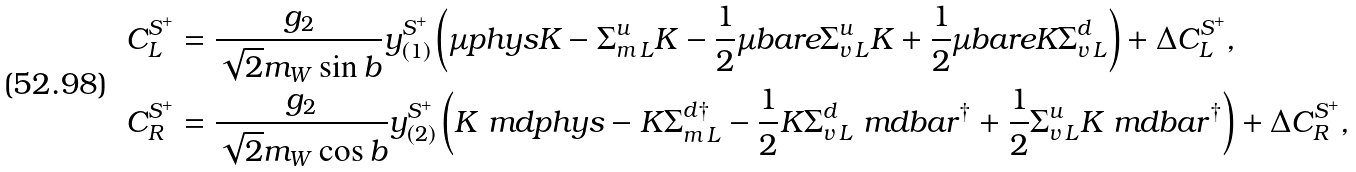Convert formula to latex. <formula><loc_0><loc_0><loc_500><loc_500>C ^ { S ^ { + } } _ { L } & = \frac { g _ { 2 } } { \sqrt { 2 } m _ { W } \sin b } y _ { ( 1 ) } ^ { S ^ { + } } \left ( \mu p h y s K - \Sigma ^ { u } _ { m \, L } K - \frac { 1 } { 2 } \mu b a r e \Sigma ^ { u } _ { v \, L } K + \frac { 1 } { 2 } \mu b a r e K \Sigma ^ { d } _ { v \, L } \right ) + \Delta C _ { L } ^ { S ^ { + } } , \\ C ^ { S ^ { + } } _ { R } & = \frac { g _ { 2 } } { \sqrt { 2 } m _ { W } \cos b } y _ { ( 2 ) } ^ { S ^ { + } } \left ( K \ m d p h y s - K \Sigma ^ { d \dag } _ { m \, L } - \frac { 1 } { 2 } K \Sigma ^ { d } _ { v \, L } \ m d b a r ^ { \dag } + \frac { 1 } { 2 } \Sigma ^ { u } _ { v \, L } K \ m d b a r ^ { \dag } \right ) + \Delta C _ { R } ^ { S ^ { + } } ,</formula> 